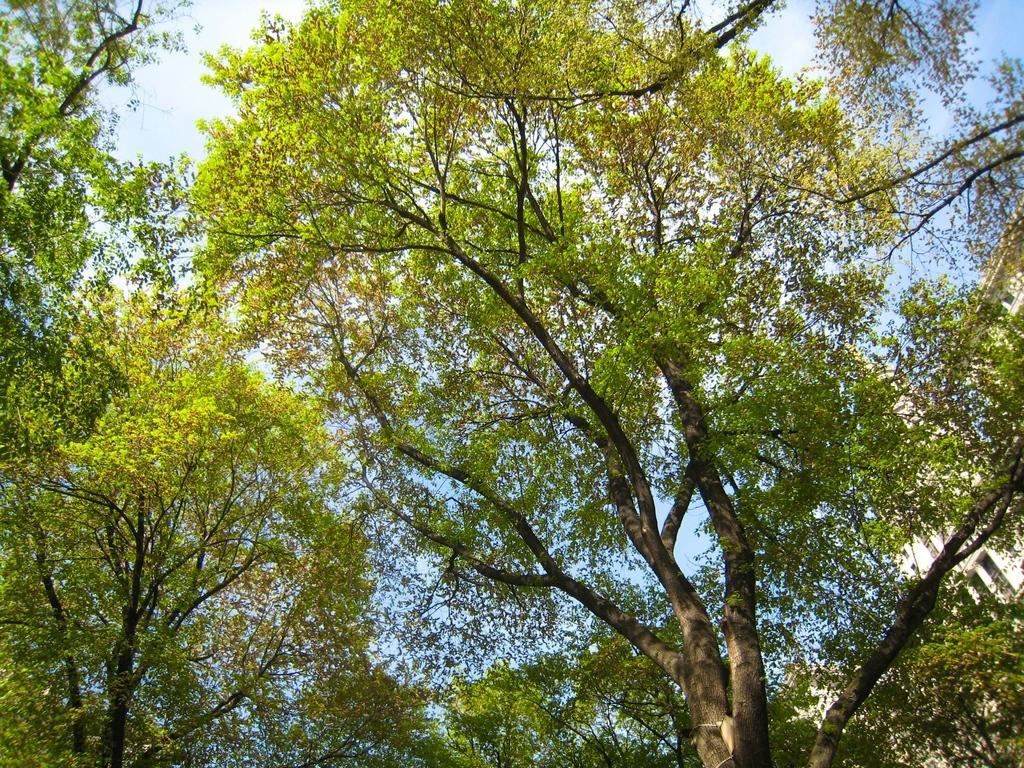How would you summarize this image in a sentence or two? In this image I can see trees and there is sky at the top. 